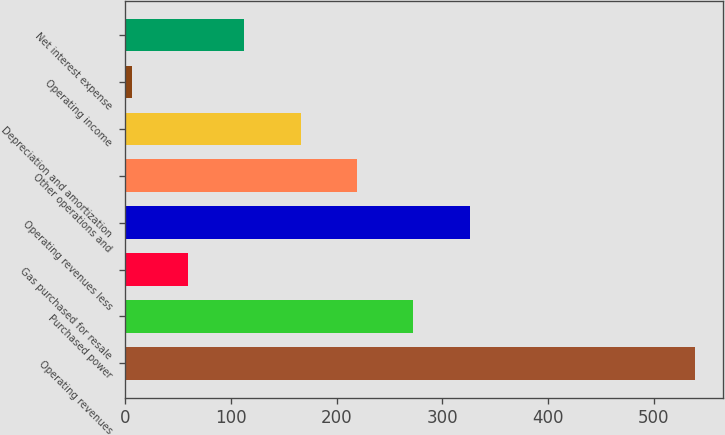<chart> <loc_0><loc_0><loc_500><loc_500><bar_chart><fcel>Operating revenues<fcel>Purchased power<fcel>Gas purchased for resale<fcel>Operating revenues less<fcel>Other operations and<fcel>Depreciation and amortization<fcel>Operating income<fcel>Net interest expense<nl><fcel>539<fcel>272.5<fcel>59.3<fcel>325.8<fcel>219.2<fcel>165.9<fcel>6<fcel>112.6<nl></chart> 